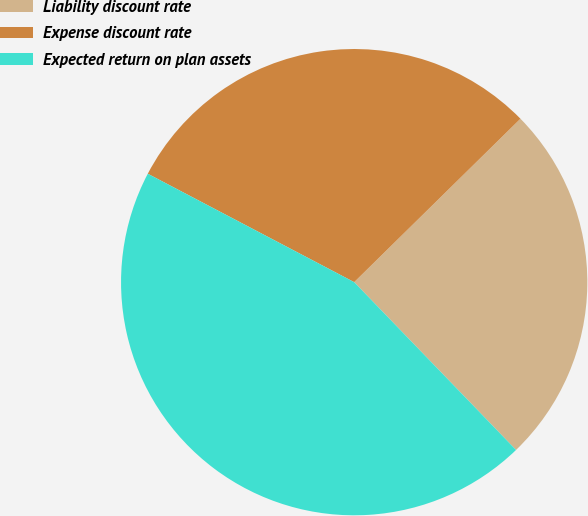Convert chart to OTSL. <chart><loc_0><loc_0><loc_500><loc_500><pie_chart><fcel>Liability discount rate<fcel>Expense discount rate<fcel>Expected return on plan assets<nl><fcel>25.15%<fcel>29.94%<fcel>44.91%<nl></chart> 